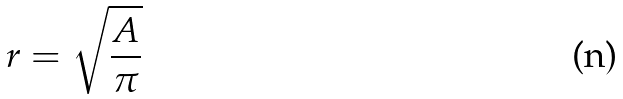Convert formula to latex. <formula><loc_0><loc_0><loc_500><loc_500>r = \sqrt { \frac { A } { \pi } }</formula> 